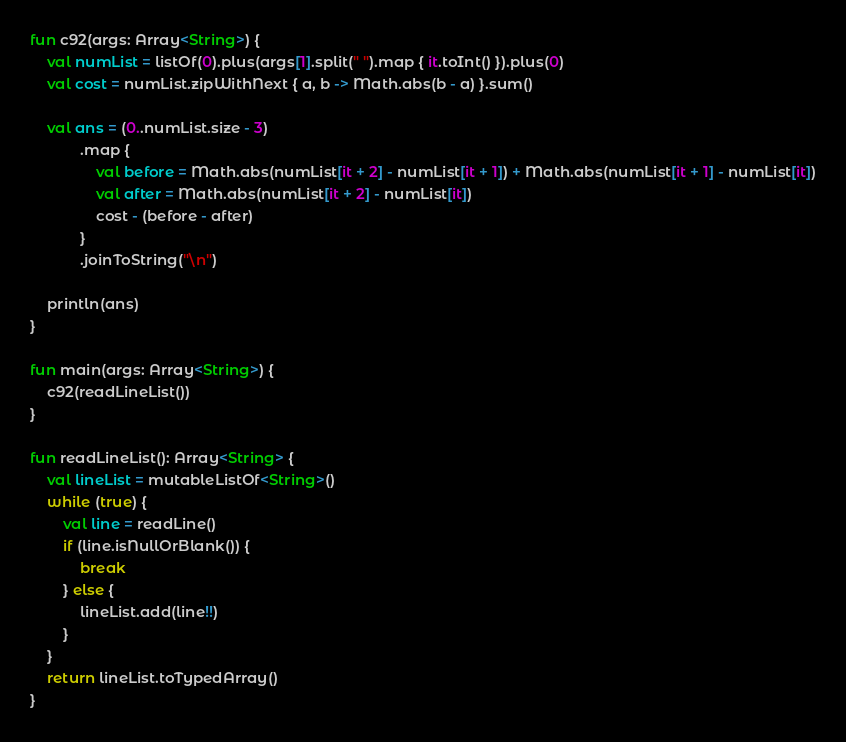Convert code to text. <code><loc_0><loc_0><loc_500><loc_500><_Kotlin_>
fun c92(args: Array<String>) {
    val numList = listOf(0).plus(args[1].split(" ").map { it.toInt() }).plus(0)
    val cost = numList.zipWithNext { a, b -> Math.abs(b - a) }.sum()

    val ans = (0..numList.size - 3)
            .map {
                val before = Math.abs(numList[it + 2] - numList[it + 1]) + Math.abs(numList[it + 1] - numList[it])
                val after = Math.abs(numList[it + 2] - numList[it])
                cost - (before - after)
            }
            .joinToString("\n")

    println(ans)
}

fun main(args: Array<String>) {
    c92(readLineList())
}

fun readLineList(): Array<String> {
    val lineList = mutableListOf<String>()
    while (true) {
        val line = readLine()
        if (line.isNullOrBlank()) {
            break
        } else {
            lineList.add(line!!)
        }
    }
    return lineList.toTypedArray()
}</code> 